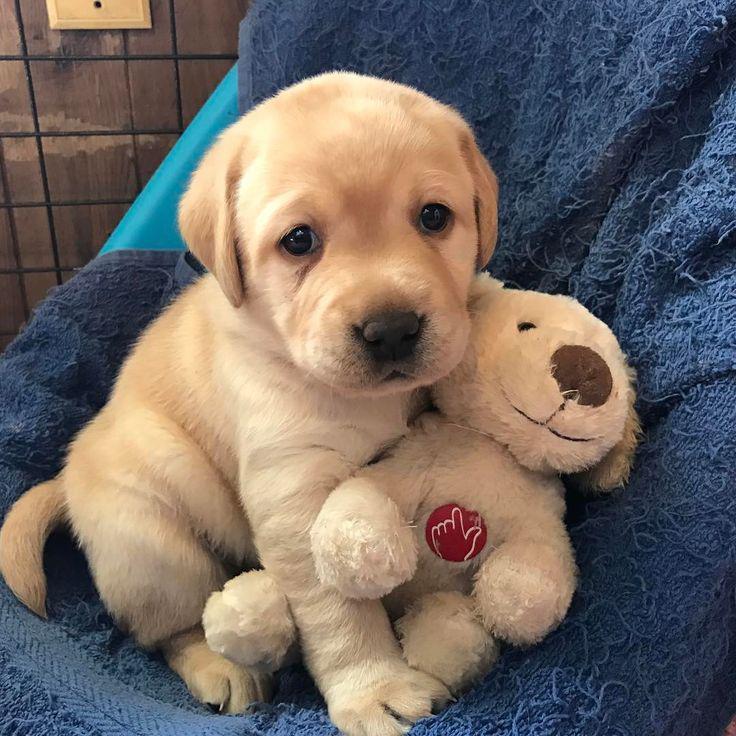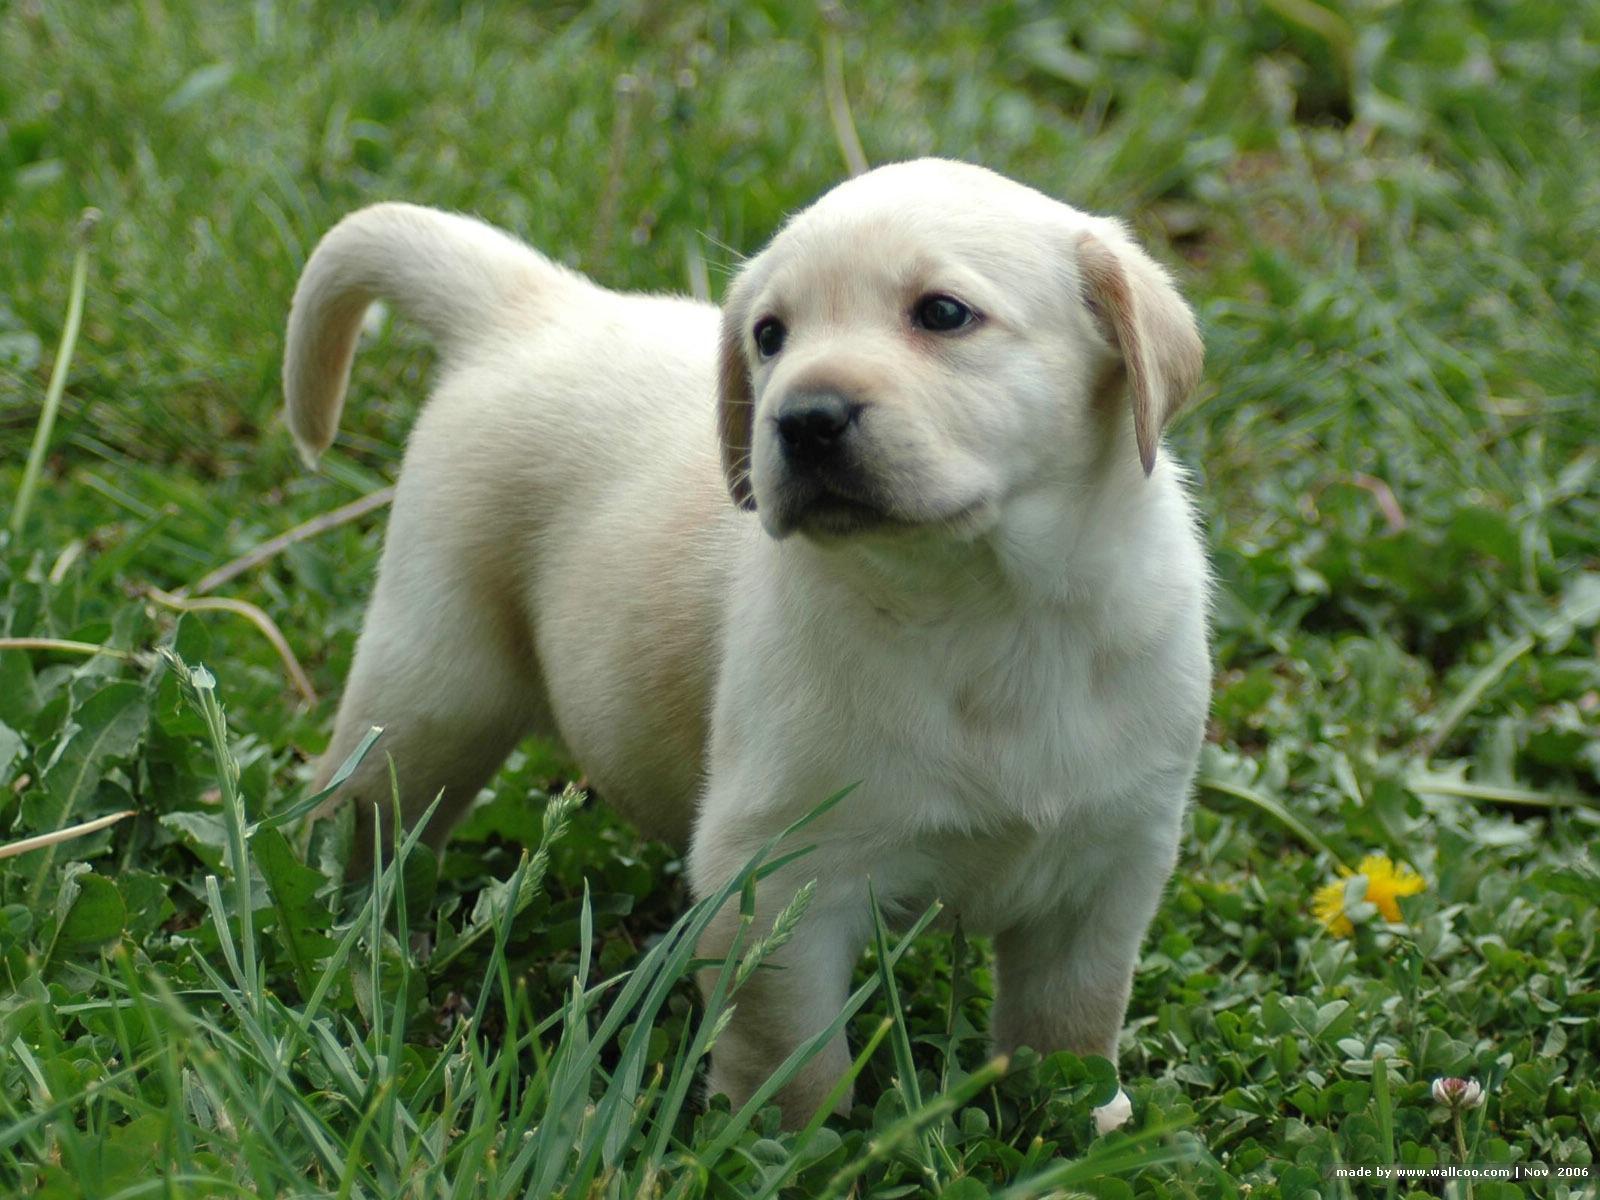The first image is the image on the left, the second image is the image on the right. For the images displayed, is the sentence "one of the dogs is showing its teeth" factually correct? Answer yes or no. No. The first image is the image on the left, the second image is the image on the right. Assess this claim about the two images: "One of the images shows a dog with a dog toy in their possession.". Correct or not? Answer yes or no. Yes. 